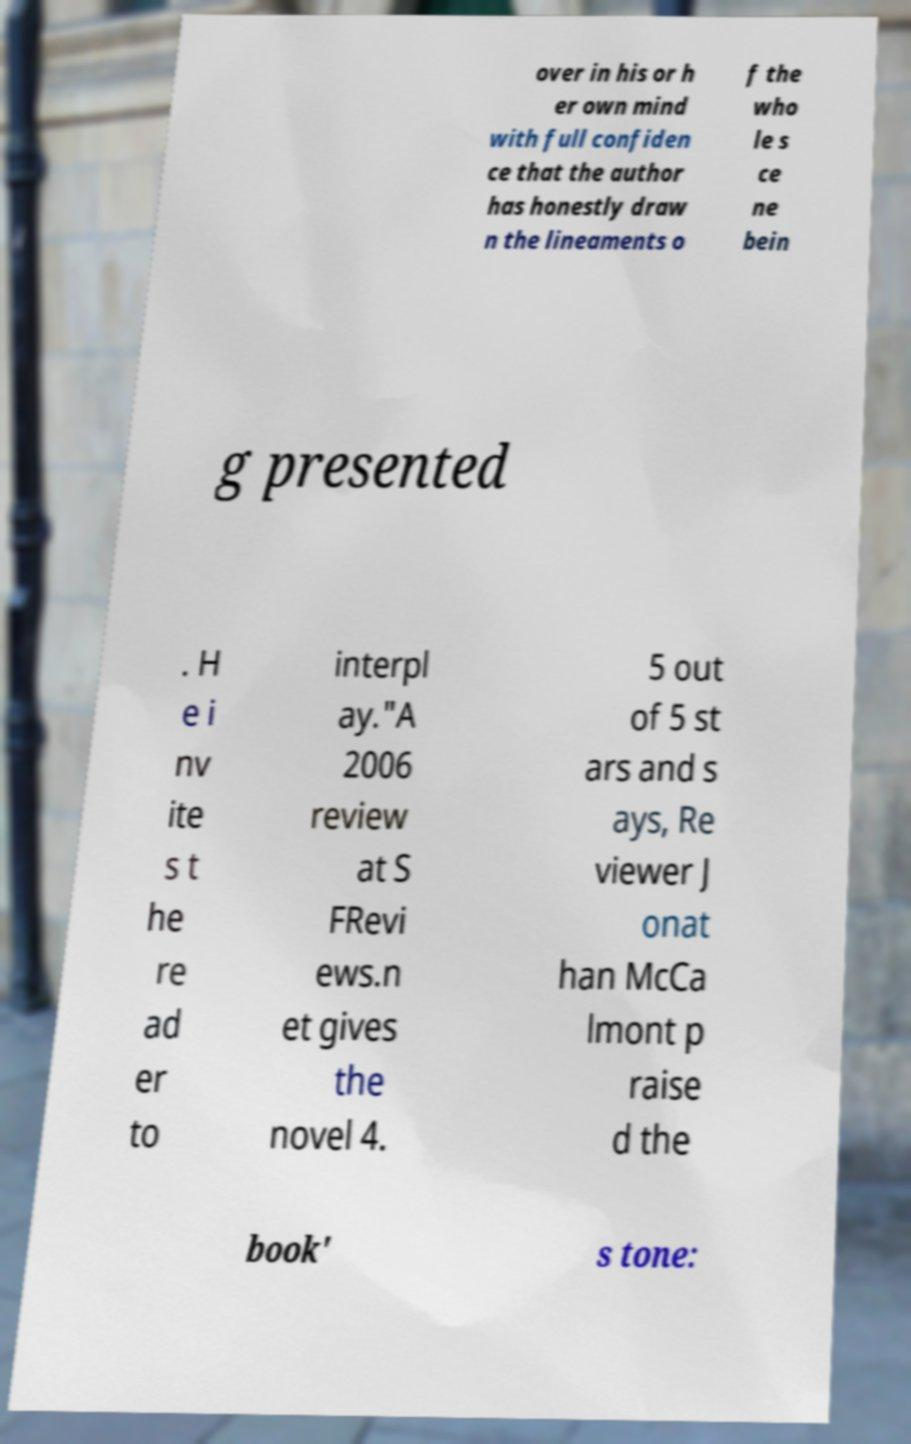I need the written content from this picture converted into text. Can you do that? over in his or h er own mind with full confiden ce that the author has honestly draw n the lineaments o f the who le s ce ne bein g presented . H e i nv ite s t he re ad er to interpl ay."A 2006 review at S FRevi ews.n et gives the novel 4. 5 out of 5 st ars and s ays, Re viewer J onat han McCa lmont p raise d the book' s tone: 